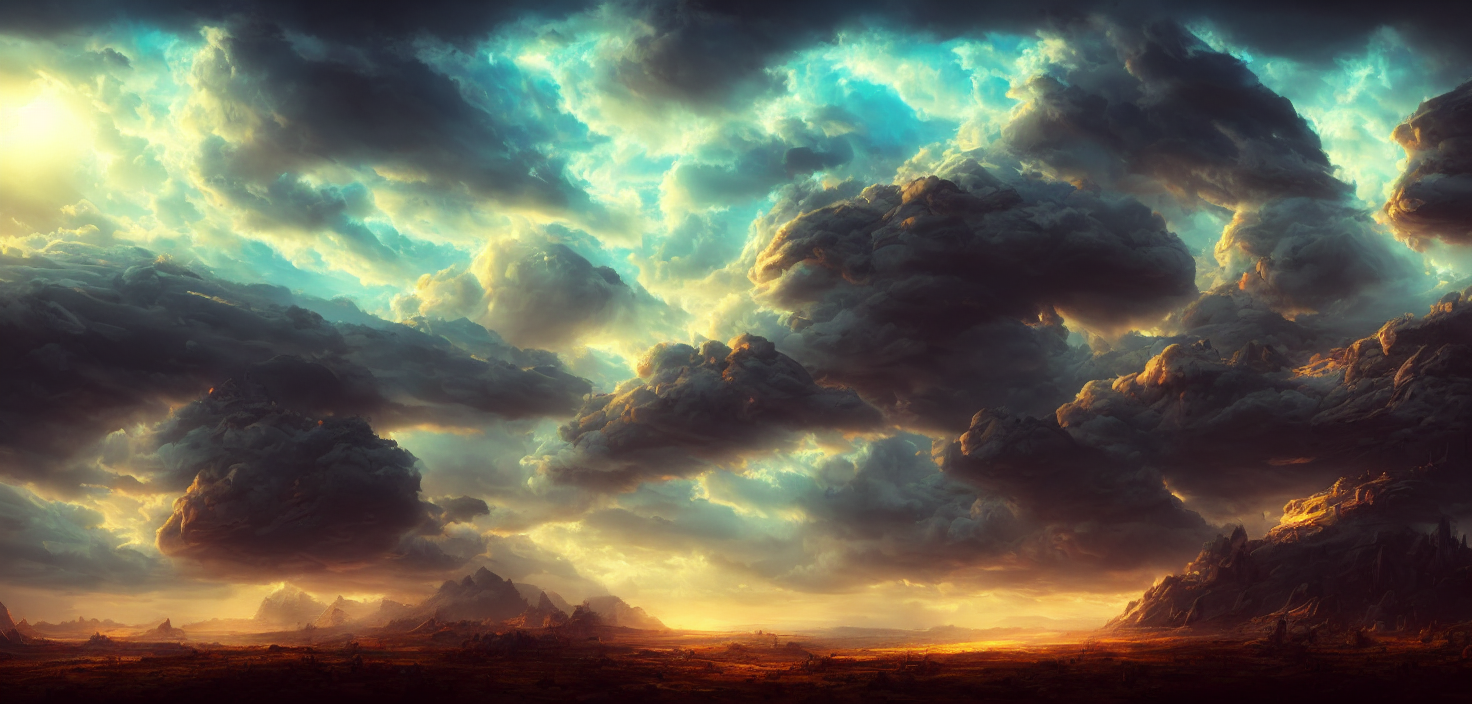How does the lighting in this image contribute to the mood? The lighting in the image plays a crucial role in establishing a dramatic and almost ethereal atmosphere. The interplay of light and shadows, particularly how the sunbeams filter through the breaks in the clouds to spotlight the landscape below, enhances the sense of grandeur and emphasizes the majesty of the natural world. It evokes a feeling of awe and could also be considered to symbolize hope or divinity shining through amidst turbulent times. What time of day does it appear to be, and why? It appears to be either sunrise or sunset, judging by the warm, golden hues near the horizon and the low angle at which the sunlight filters through the clouds. The long shadows cast across the terrain and the rich, contrasting colors commonly associated with the 'golden hour' suggest that the sun is low in the sky, providing a soft, diffused light that enhances the textures of both the clouds and the landscape. 